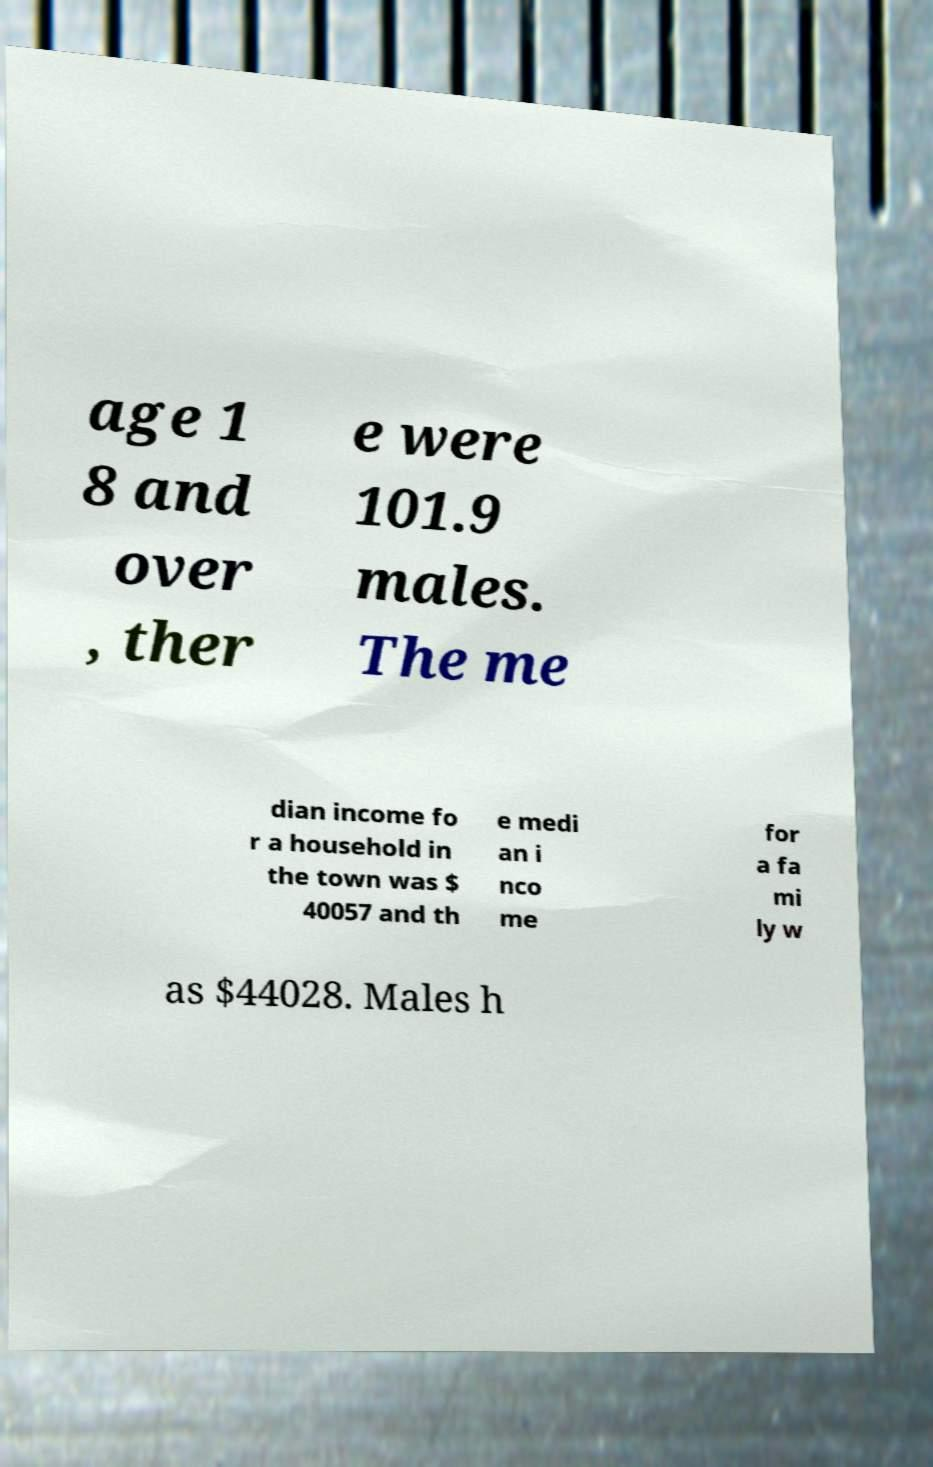Can you read and provide the text displayed in the image?This photo seems to have some interesting text. Can you extract and type it out for me? age 1 8 and over , ther e were 101.9 males. The me dian income fo r a household in the town was $ 40057 and th e medi an i nco me for a fa mi ly w as $44028. Males h 